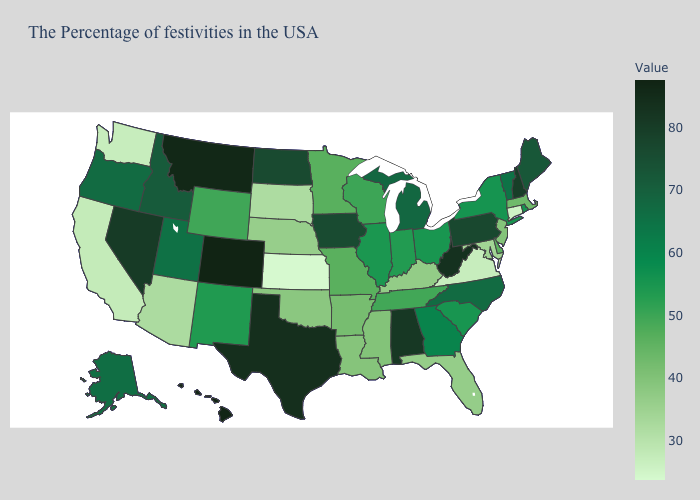Does West Virginia have the lowest value in the South?
Write a very short answer. No. Does Michigan have the highest value in the MidWest?
Concise answer only. No. Is the legend a continuous bar?
Answer briefly. Yes. Does the map have missing data?
Answer briefly. No. Which states have the lowest value in the USA?
Short answer required. Kansas. Among the states that border Tennessee , which have the highest value?
Answer briefly. Alabama. 